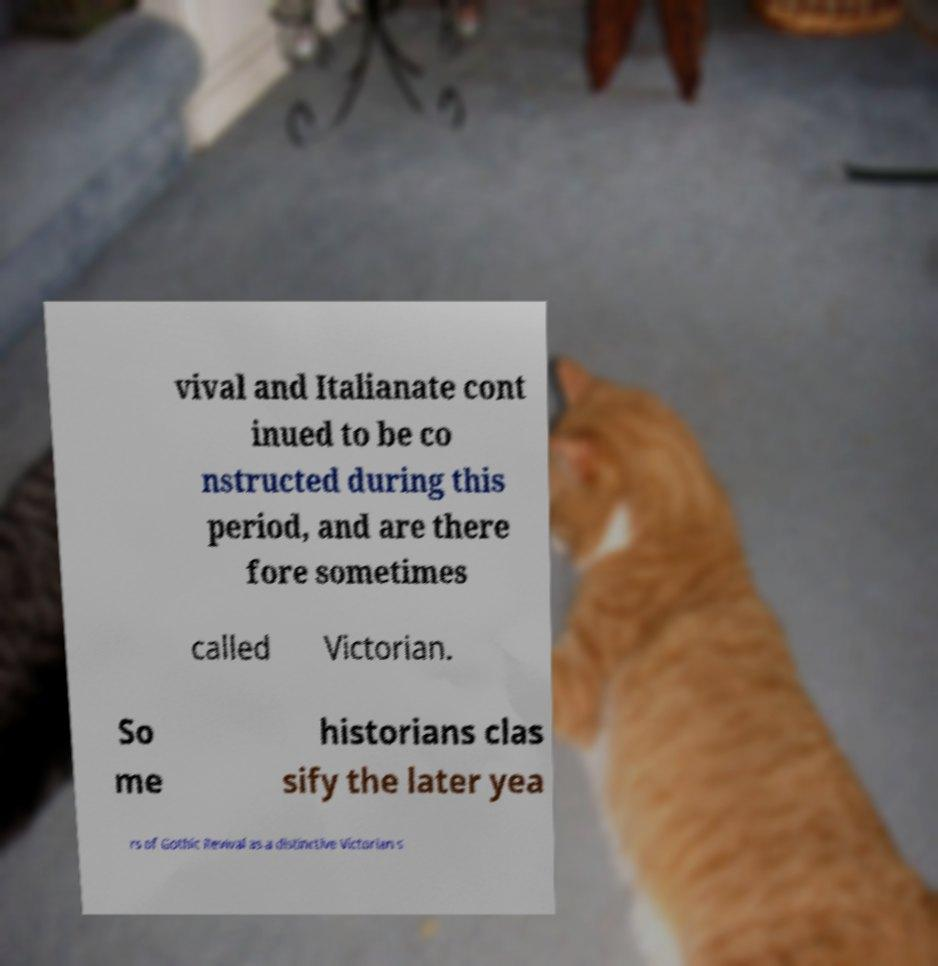Could you extract and type out the text from this image? vival and Italianate cont inued to be co nstructed during this period, and are there fore sometimes called Victorian. So me historians clas sify the later yea rs of Gothic Revival as a distinctive Victorian s 